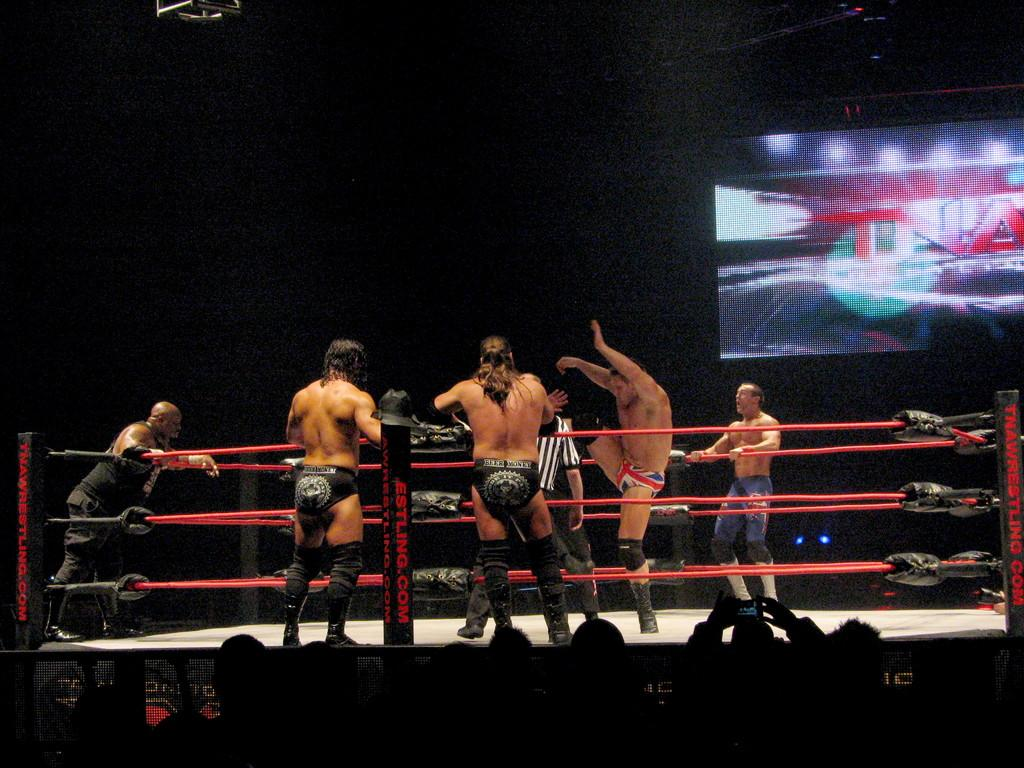<image>
Share a concise interpretation of the image provided. Wrestlers on a stage behind a screen that says TNA. 